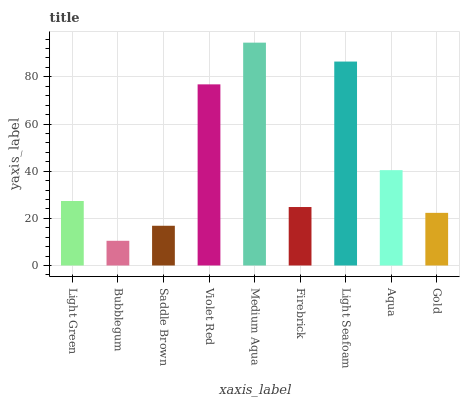Is Bubblegum the minimum?
Answer yes or no. Yes. Is Medium Aqua the maximum?
Answer yes or no. Yes. Is Saddle Brown the minimum?
Answer yes or no. No. Is Saddle Brown the maximum?
Answer yes or no. No. Is Saddle Brown greater than Bubblegum?
Answer yes or no. Yes. Is Bubblegum less than Saddle Brown?
Answer yes or no. Yes. Is Bubblegum greater than Saddle Brown?
Answer yes or no. No. Is Saddle Brown less than Bubblegum?
Answer yes or no. No. Is Light Green the high median?
Answer yes or no. Yes. Is Light Green the low median?
Answer yes or no. Yes. Is Light Seafoam the high median?
Answer yes or no. No. Is Light Seafoam the low median?
Answer yes or no. No. 